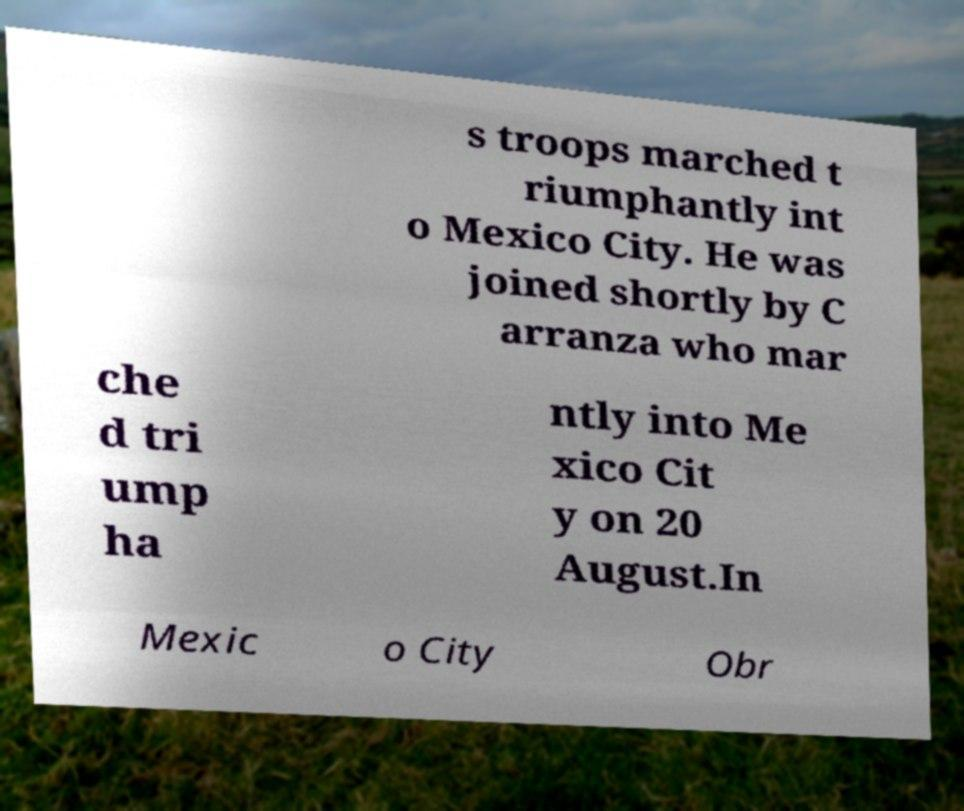Could you assist in decoding the text presented in this image and type it out clearly? s troops marched t riumphantly int o Mexico City. He was joined shortly by C arranza who mar che d tri ump ha ntly into Me xico Cit y on 20 August.In Mexic o City Obr 